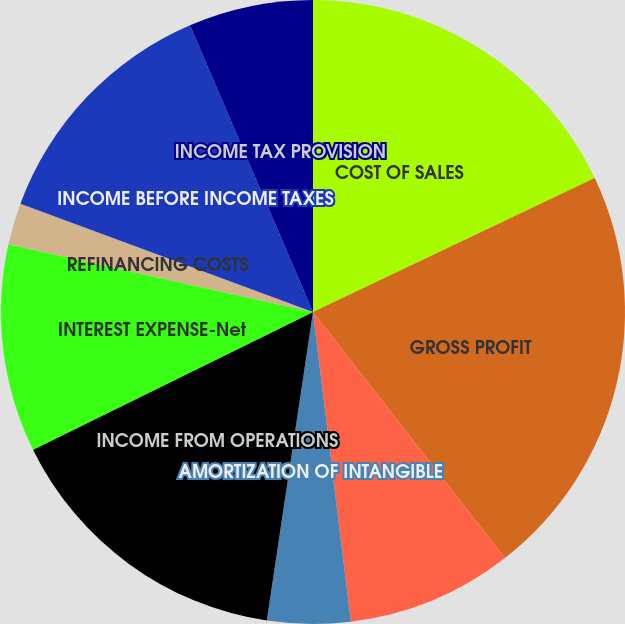Convert chart to OTSL. <chart><loc_0><loc_0><loc_500><loc_500><pie_chart><fcel>COST OF SALES<fcel>GROSS PROFIT<fcel>SELLING AND ADMINISTRATIVE<fcel>AMORTIZATION OF INTANGIBLE<fcel>INCOME FROM OPERATIONS<fcel>INTEREST EXPENSE-Net<fcel>REFINANCING COSTS<fcel>INCOME BEFORE INCOME TAXES<fcel>INCOME TAX PROVISION<fcel>Basic and diluted<nl><fcel>17.93%<fcel>21.52%<fcel>8.61%<fcel>4.3%<fcel>15.36%<fcel>10.76%<fcel>2.15%<fcel>12.91%<fcel>6.45%<fcel>0.0%<nl></chart> 